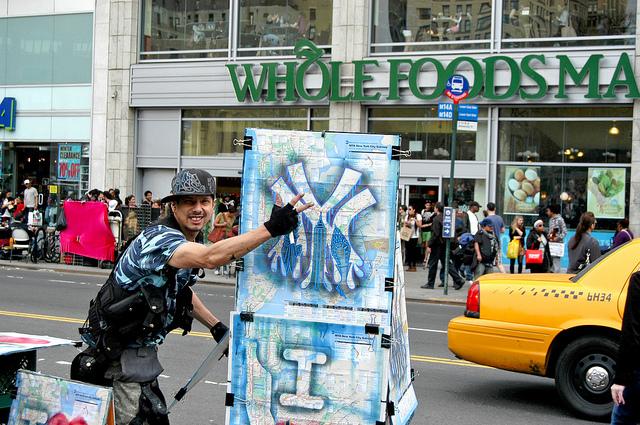What color gloves is the wearing?
Write a very short answer. Black. Could this be overseas?
Answer briefly. No. What movie is advertised on the taxi?
Answer briefly. None. What has he used to create his art?
Quick response, please. Spray paint. How many bus routes stop here?
Be succinct. 2. Is there a taxi cab in the picture?
Keep it brief. Yes. 